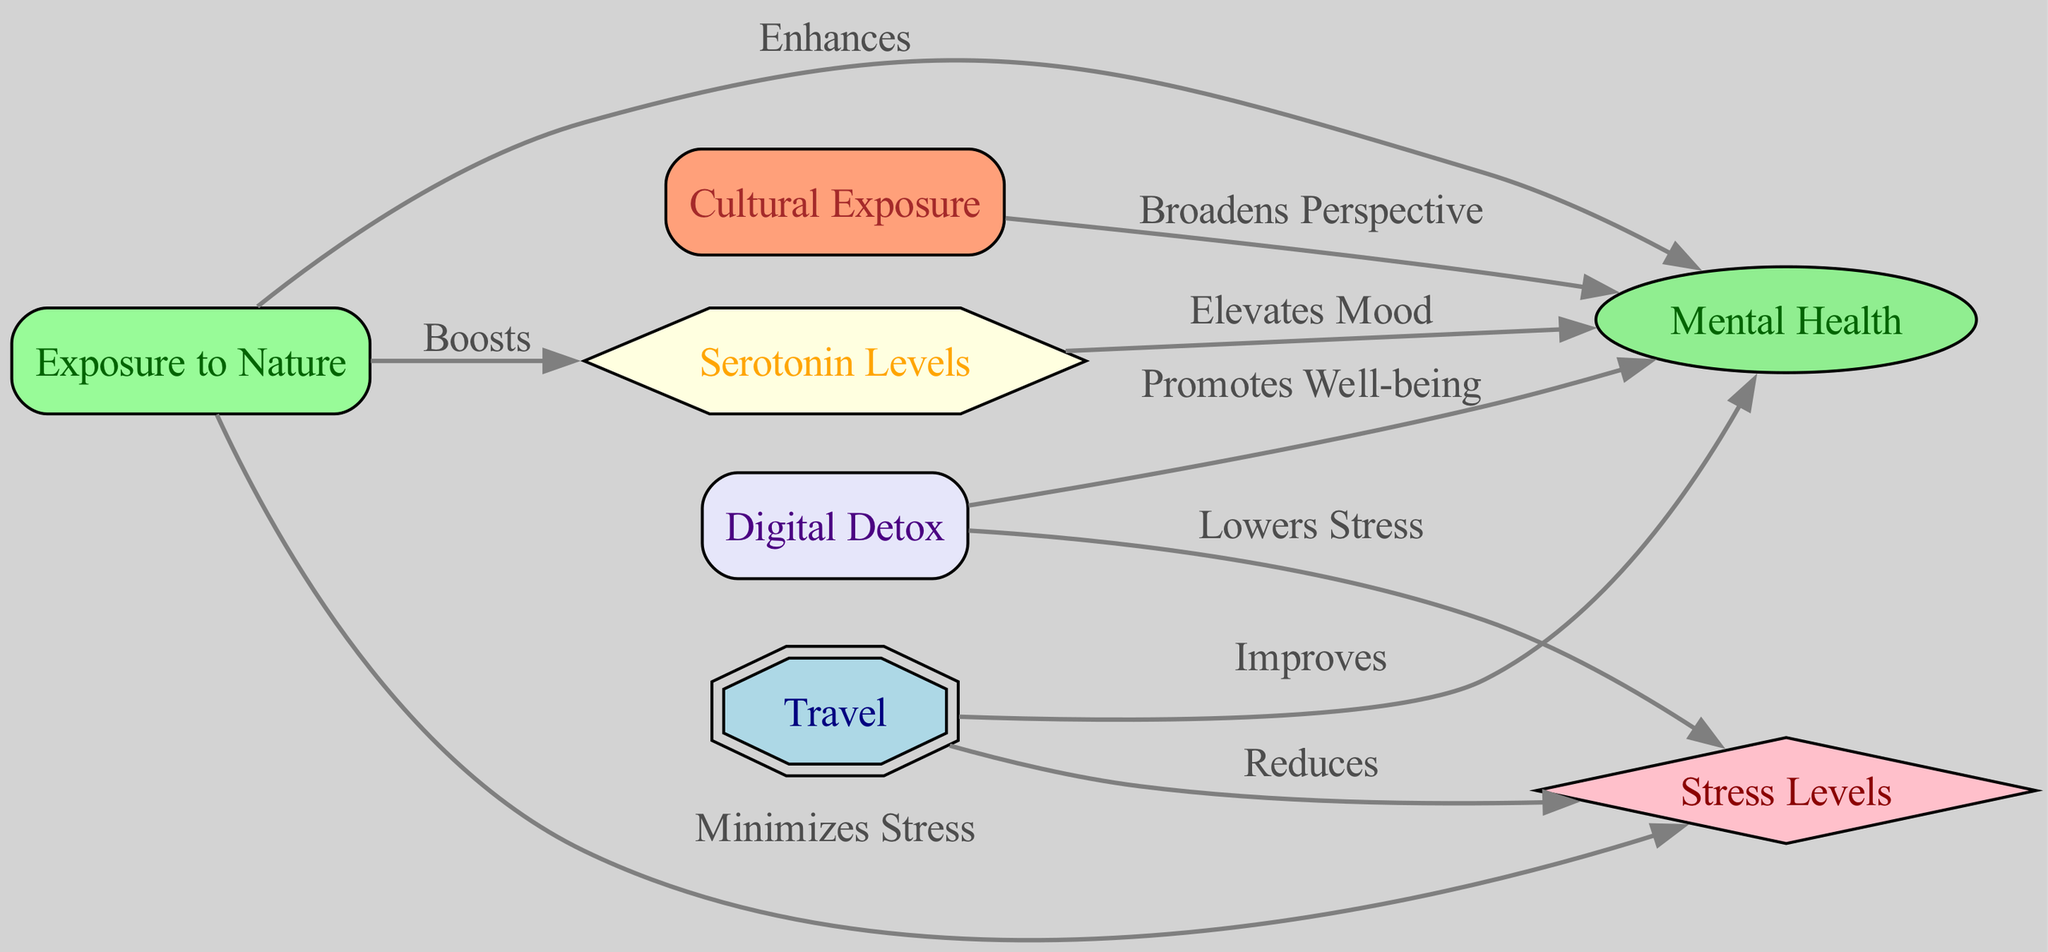What is the total number of nodes in the diagram? The diagram has seven nodes representing different concepts related to travel and mental health. By counting the number of distinct nodes (Travel, Mental Health, Stress Levels, Serotonin Levels, Exposure to Nature, Cultural Exposure, Digital Detox), we find a total of seven.
Answer: 7 Which node is improved by travel? The diagram shows a directed edge from the node "Travel" to the node "Mental Health" with the label "Improves." This indicates that travel is known to improve mental health.
Answer: Mental Health How does exposure to nature affect stress levels? The diagram indicates a directed edge from "Exposure to Nature" to "Stress Levels" with the label "Minimizes Stress." This shows that exposure to nature helps in reducing stress levels.
Answer: Minimizes Stress What promotes well-being according to the diagram? There is an edge from "Digital Detox" to "Mental Health" labeled "Promotes Well-being." This suggests that taking a digital detox is beneficial for improving mental health and promoting overall well-being.
Answer: Promotes Well-being What is the relationship between serotonin levels and mental health? The diagram illustrates an edge from "Serotonin Levels" to "Mental Health" with the label "Elevates Mood." This means that higher serotonin levels are associated with improved mood and therefore better mental health.
Answer: Elevates Mood Which two nodes are connected by an edge that indicates a reduction in stress? The diagram shows two edges that indicate a reduction in stress: one from "Travel" to "Stress Levels" labeled "Reduces," and another from "Digital Detox" to "Stress Levels" labeled "Lowers." Both these edges suggest methods to reduce stress levels.
Answer: Travel, Digital Detox Which elements enhance mental health? The diagram indicates that both "Exposure to Nature" and "Cultural Exposure" have edges directed towards "Mental Health" with labels "Enhances" and "Broadens Perspective," respectively. This signifies that these experiences positively contribute to mental health.
Answer: Exposure to Nature, Cultural Exposure 